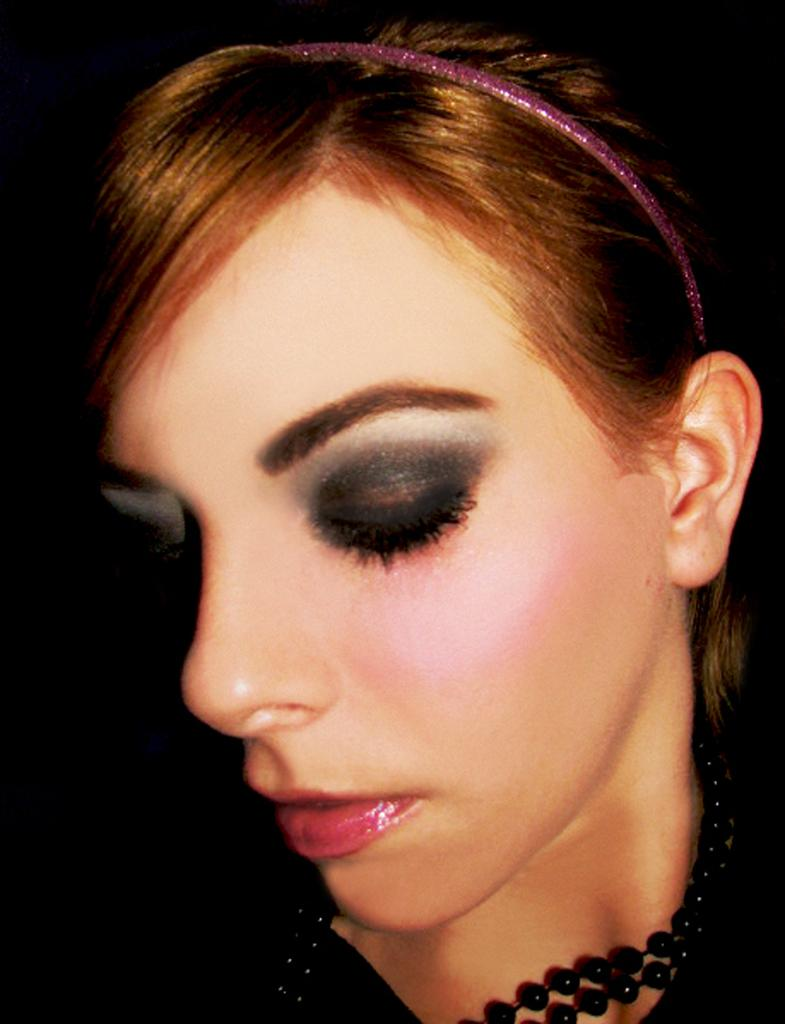What is the main subject of the image? The main subject of the image is a girl's face. Can you describe the background of the image? The background of the image is dark. What song is the girl singing in the image? There is no indication in the image that the girl is singing a song. Can you describe the mailbox located near the girl in the image? There is no mailbox present in the image. 